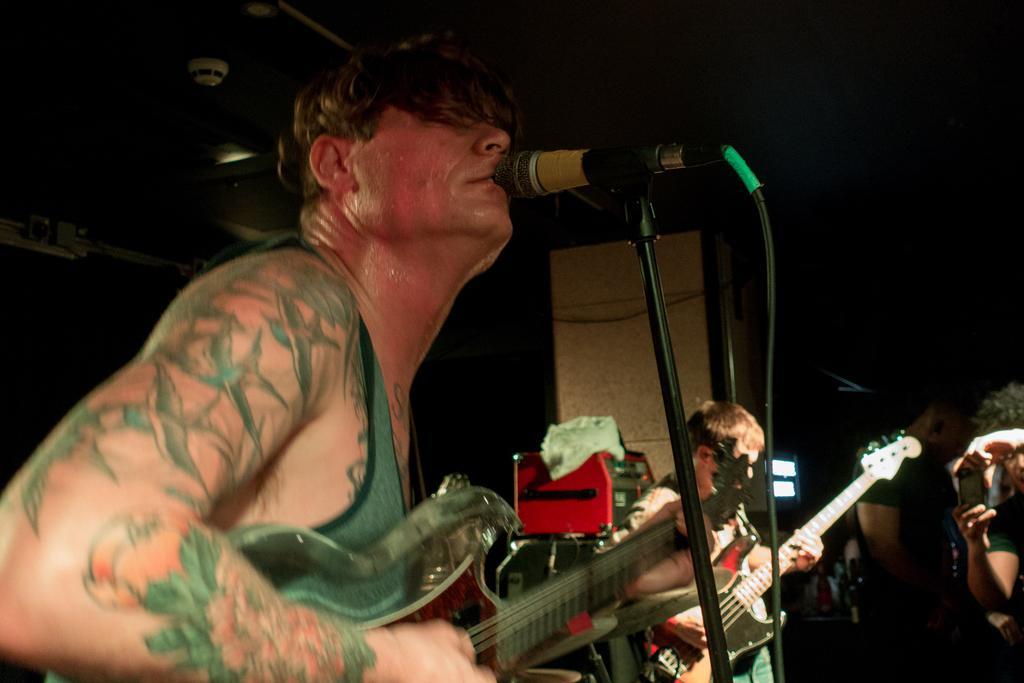Can you describe this image briefly? In this image there are two persons who are playing guitar and in front of him there is a microphone. 